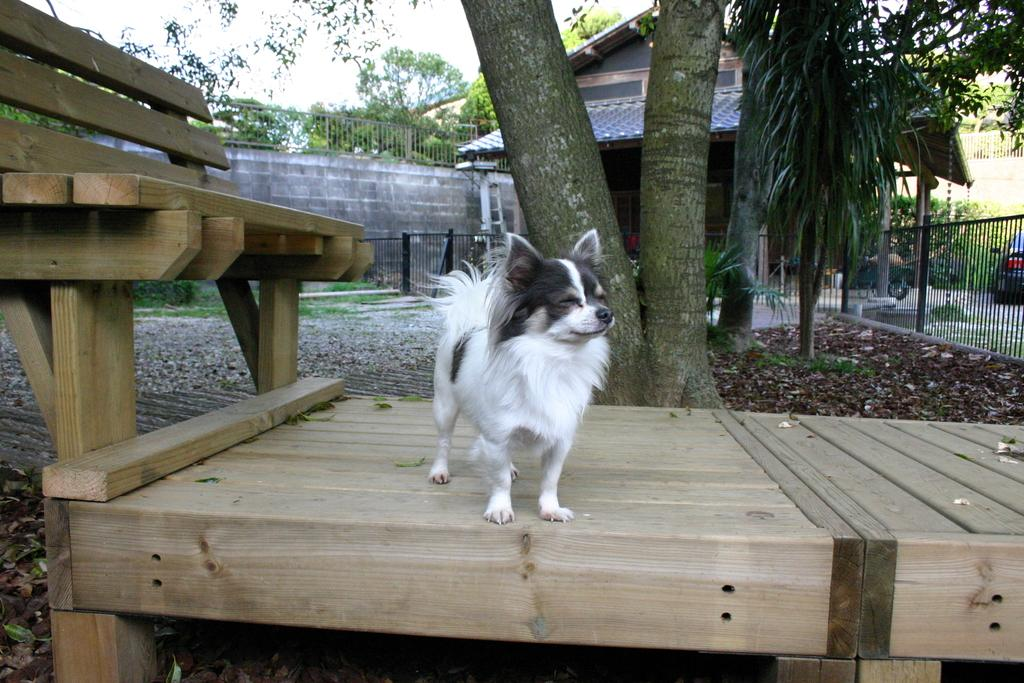What animal is sitting on the bench in the image? There is a dog on the bench in the image. What can be seen in the distance behind the bench? There is a house and trees in the background of the image. What part of the natural environment is visible in the image? The sky is visible in the background of the image. What expert advice can be seen in the image? There is no expert advice present in the image; it features a dog on a bench with a house, trees, and sky in the background. 